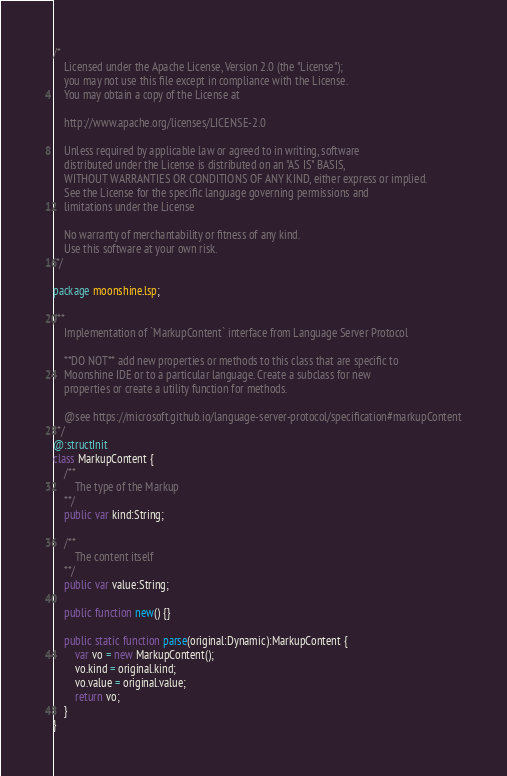Convert code to text. <code><loc_0><loc_0><loc_500><loc_500><_Haxe_>/*
	Licensed under the Apache License, Version 2.0 (the "License");
	you may not use this file except in compliance with the License.
	You may obtain a copy of the License at

	http://www.apache.org/licenses/LICENSE-2.0

	Unless required by applicable law or agreed to in writing, software
	distributed under the License is distributed on an "AS IS" BASIS,
	WITHOUT WARRANTIES OR CONDITIONS OF ANY KIND, either express or implied.
	See the License for the specific language governing permissions and
	limitations under the License

	No warranty of merchantability or fitness of any kind.
	Use this software at your own risk.
 */

package moonshine.lsp;

/**
	Implementation of `MarkupContent` interface from Language Server Protocol

	**DO NOT** add new properties or methods to this class that are specific to
	Moonshine IDE or to a particular language. Create a subclass for new
	properties or create a utility function for methods.
	 
	@see https://microsoft.github.io/language-server-protocol/specification#markupContent
**/
@:structInit
class MarkupContent {
	/**
		The type of the Markup
	**/
	public var kind:String;

	/**
		The content itself
	**/
	public var value:String;

	public function new() {}

	public static function parse(original:Dynamic):MarkupContent {
		var vo = new MarkupContent();
		vo.kind = original.kind;
		vo.value = original.value;
		return vo;
	}
}
</code> 